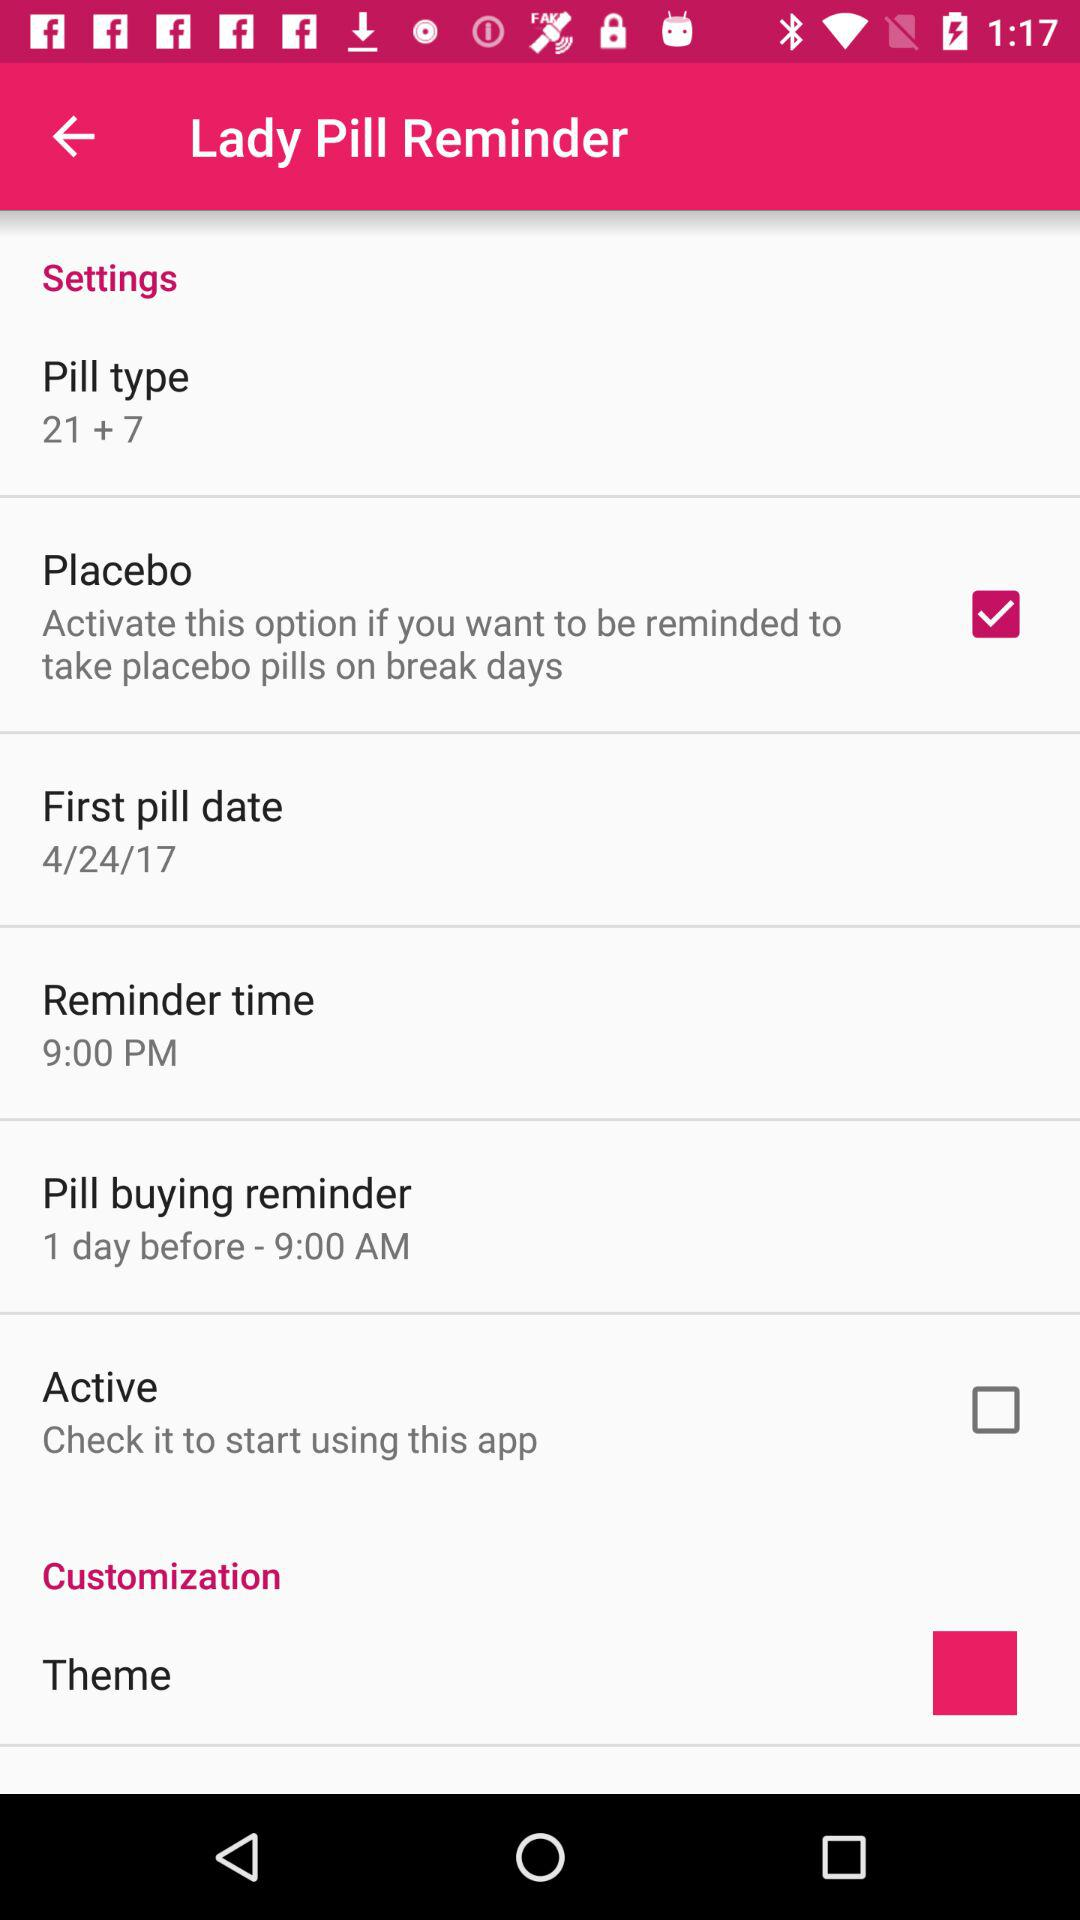What is the status of the "Placebo"? The status is "on". 